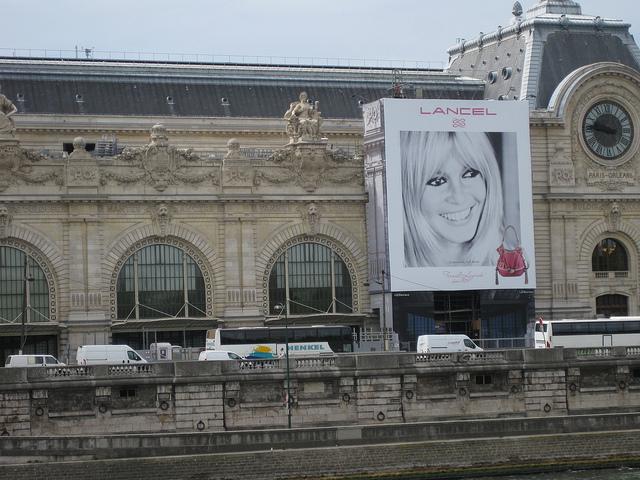How many vehicles are in the photo?
Concise answer only. 5. Is the building fancy or rustic?
Give a very brief answer. Fancy. What brand is being advertised?
Give a very brief answer. Lancel. 